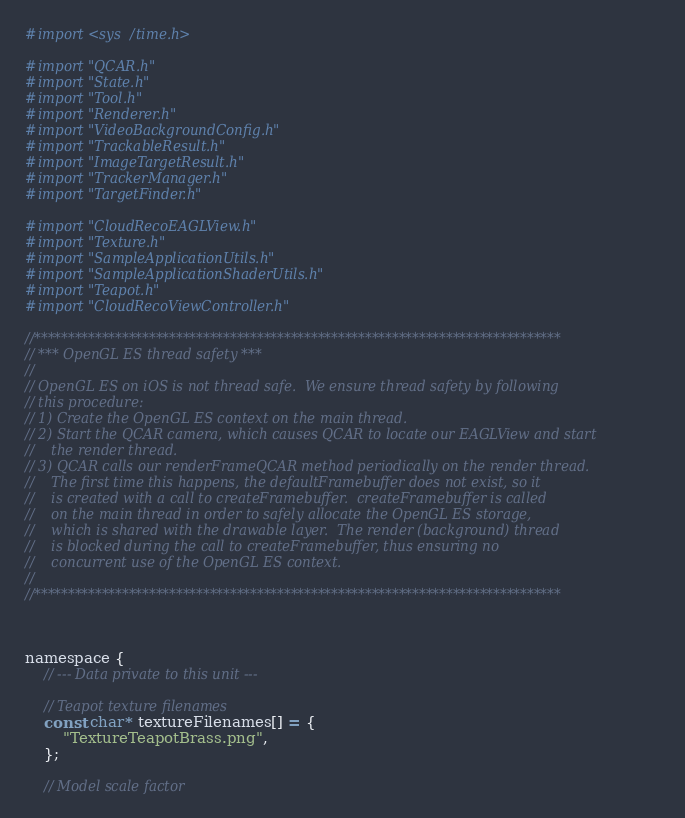Convert code to text. <code><loc_0><loc_0><loc_500><loc_500><_ObjectiveC_>#import <sys/time.h>

#import "QCAR.h"
#import "State.h"
#import "Tool.h"
#import "Renderer.h"
#import "VideoBackgroundConfig.h"
#import "TrackableResult.h"
#import "ImageTargetResult.h"
#import "TrackerManager.h"
#import "TargetFinder.h"

#import "CloudRecoEAGLView.h"
#import "Texture.h"
#import "SampleApplicationUtils.h"
#import "SampleApplicationShaderUtils.h"
#import "Teapot.h"
#import "CloudRecoViewController.h"

//******************************************************************************
// *** OpenGL ES thread safety ***
//
// OpenGL ES on iOS is not thread safe.  We ensure thread safety by following
// this procedure:
// 1) Create the OpenGL ES context on the main thread.
// 2) Start the QCAR camera, which causes QCAR to locate our EAGLView and start
//    the render thread.
// 3) QCAR calls our renderFrameQCAR method periodically on the render thread.
//    The first time this happens, the defaultFramebuffer does not exist, so it
//    is created with a call to createFramebuffer.  createFramebuffer is called
//    on the main thread in order to safely allocate the OpenGL ES storage,
//    which is shared with the drawable layer.  The render (background) thread
//    is blocked during the call to createFramebuffer, thus ensuring no
//    concurrent use of the OpenGL ES context.
//
//******************************************************************************



namespace {
    // --- Data private to this unit ---
    
    // Teapot texture filenames
    const char* textureFilenames[] = {
        "TextureTeapotBrass.png",
    };
    
    // Model scale factor</code> 